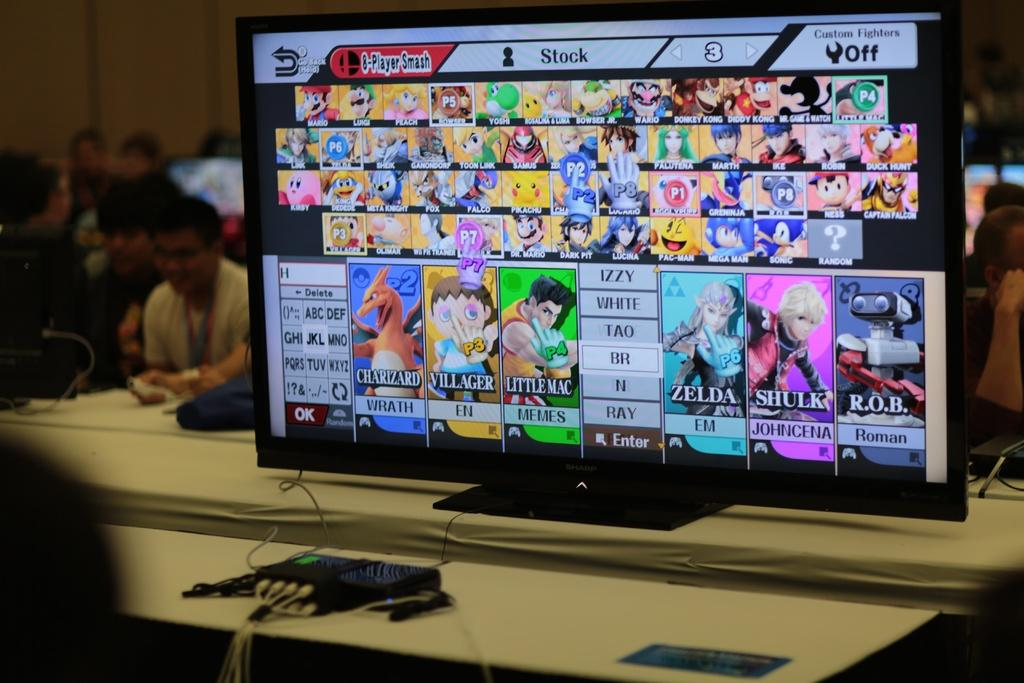<image>
Describe the image concisely. the name white is on the screen with many other graphics 